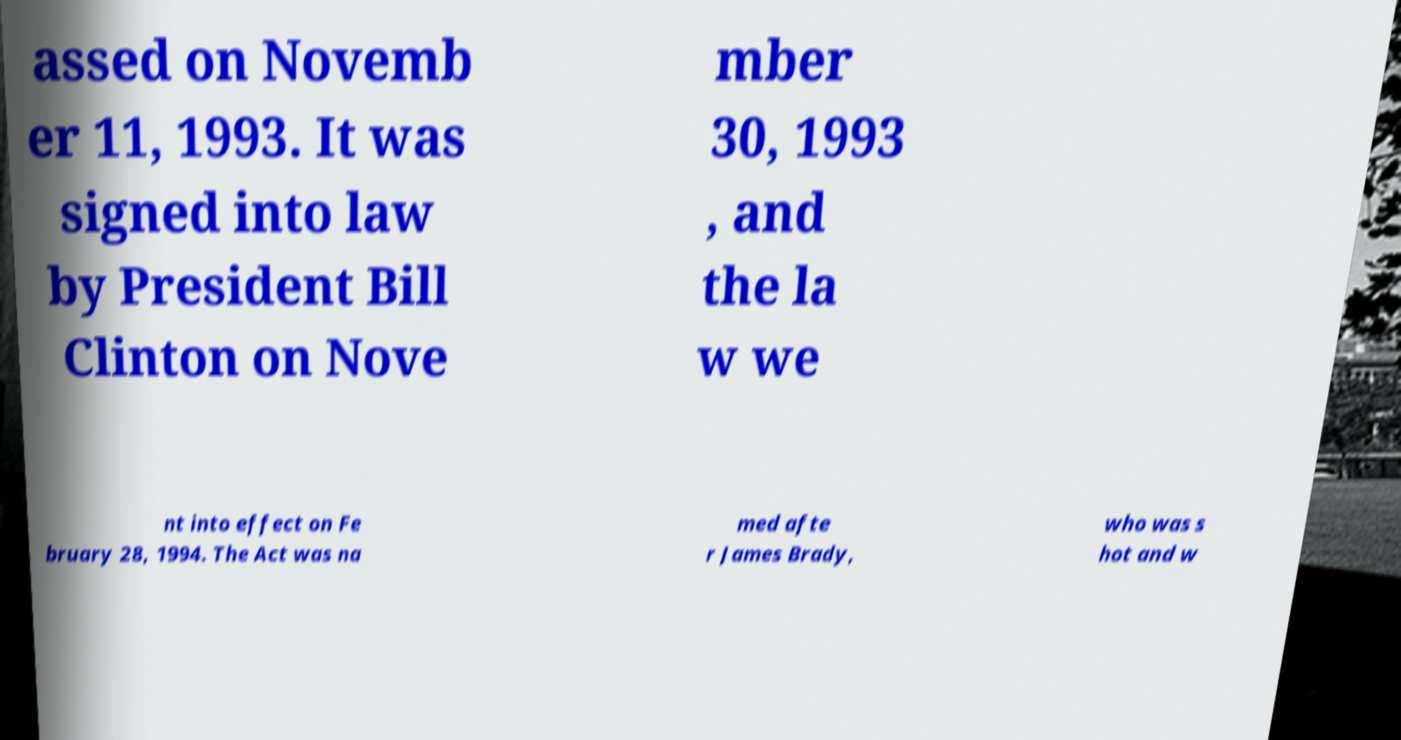Could you assist in decoding the text presented in this image and type it out clearly? assed on Novemb er 11, 1993. It was signed into law by President Bill Clinton on Nove mber 30, 1993 , and the la w we nt into effect on Fe bruary 28, 1994. The Act was na med afte r James Brady, who was s hot and w 